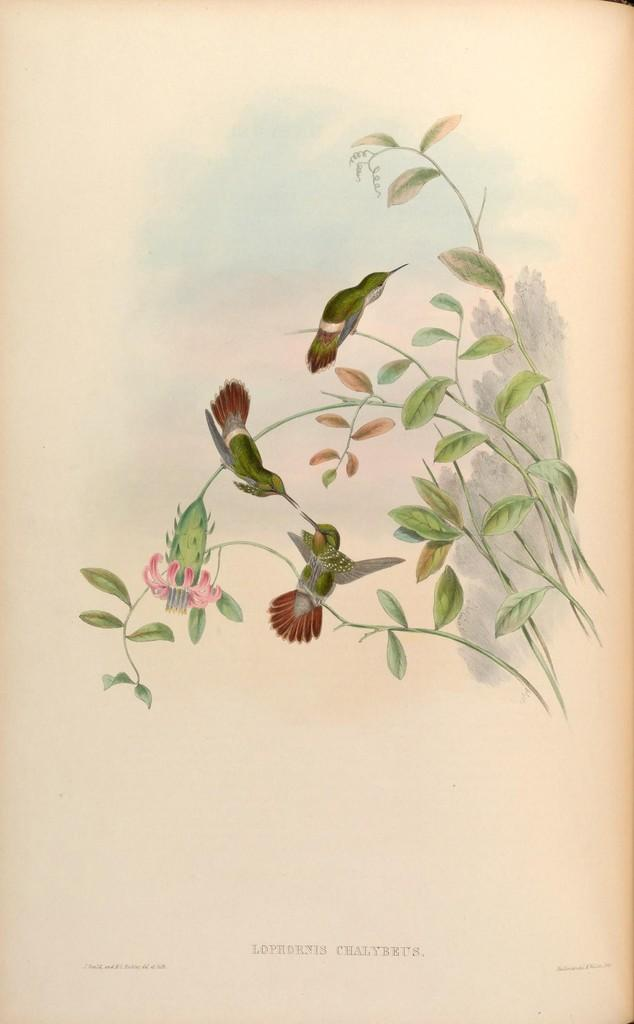What is the main subject of the image? The image contains a painting. What is being depicted in the painting? The painting depicts birds. Where are the birds located in the painting? The birds are standing on the branches of a plant. How much money is being exchanged between the birds in the painting? There is no exchange of money depicted in the painting; it features birds standing on the branches of a plant. 